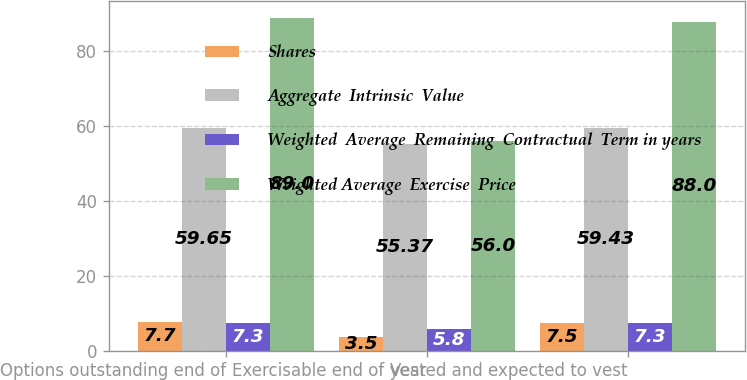Convert chart. <chart><loc_0><loc_0><loc_500><loc_500><stacked_bar_chart><ecel><fcel>Options outstanding end of<fcel>Exercisable end of year<fcel>Vested and expected to vest<nl><fcel>Shares<fcel>7.7<fcel>3.5<fcel>7.5<nl><fcel>Aggregate  Intrinsic  Value<fcel>59.65<fcel>55.37<fcel>59.43<nl><fcel>Weighted  Average  Remaining  Contractual  Term in years<fcel>7.3<fcel>5.8<fcel>7.3<nl><fcel>Weighted Average  Exercise  Price<fcel>89<fcel>56<fcel>88<nl></chart> 